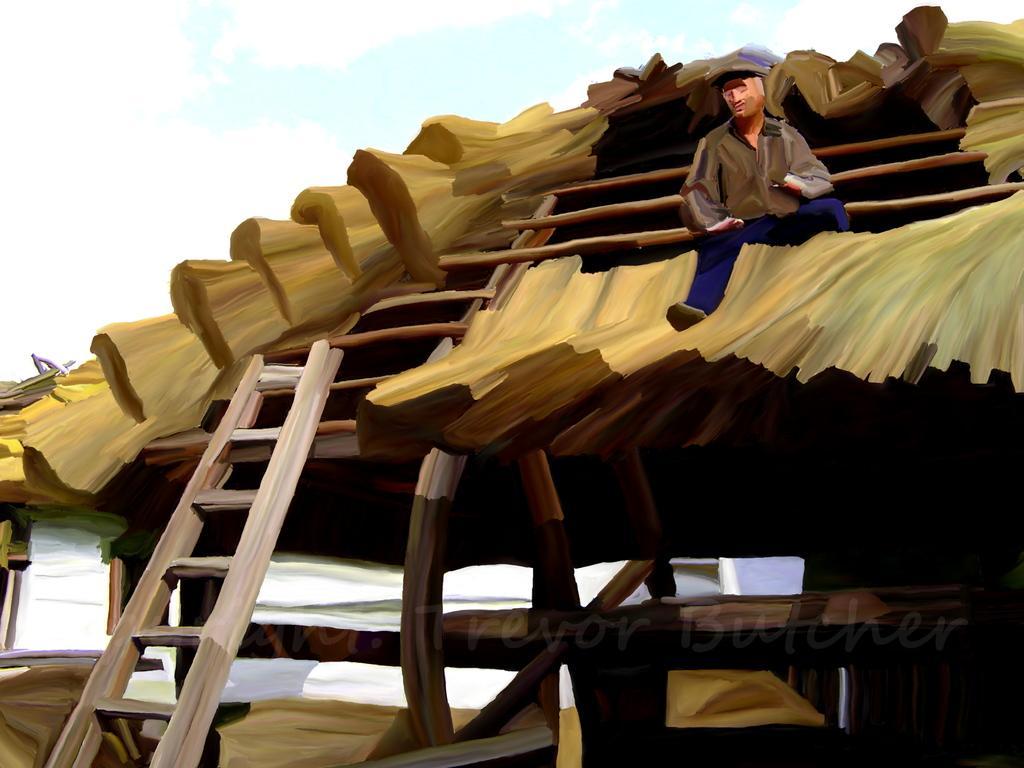Could you give a brief overview of what you see in this image? In this picture, this is a painting and in the painting a man is sitting on the roof top, ladder and behind the person there is a sky. 